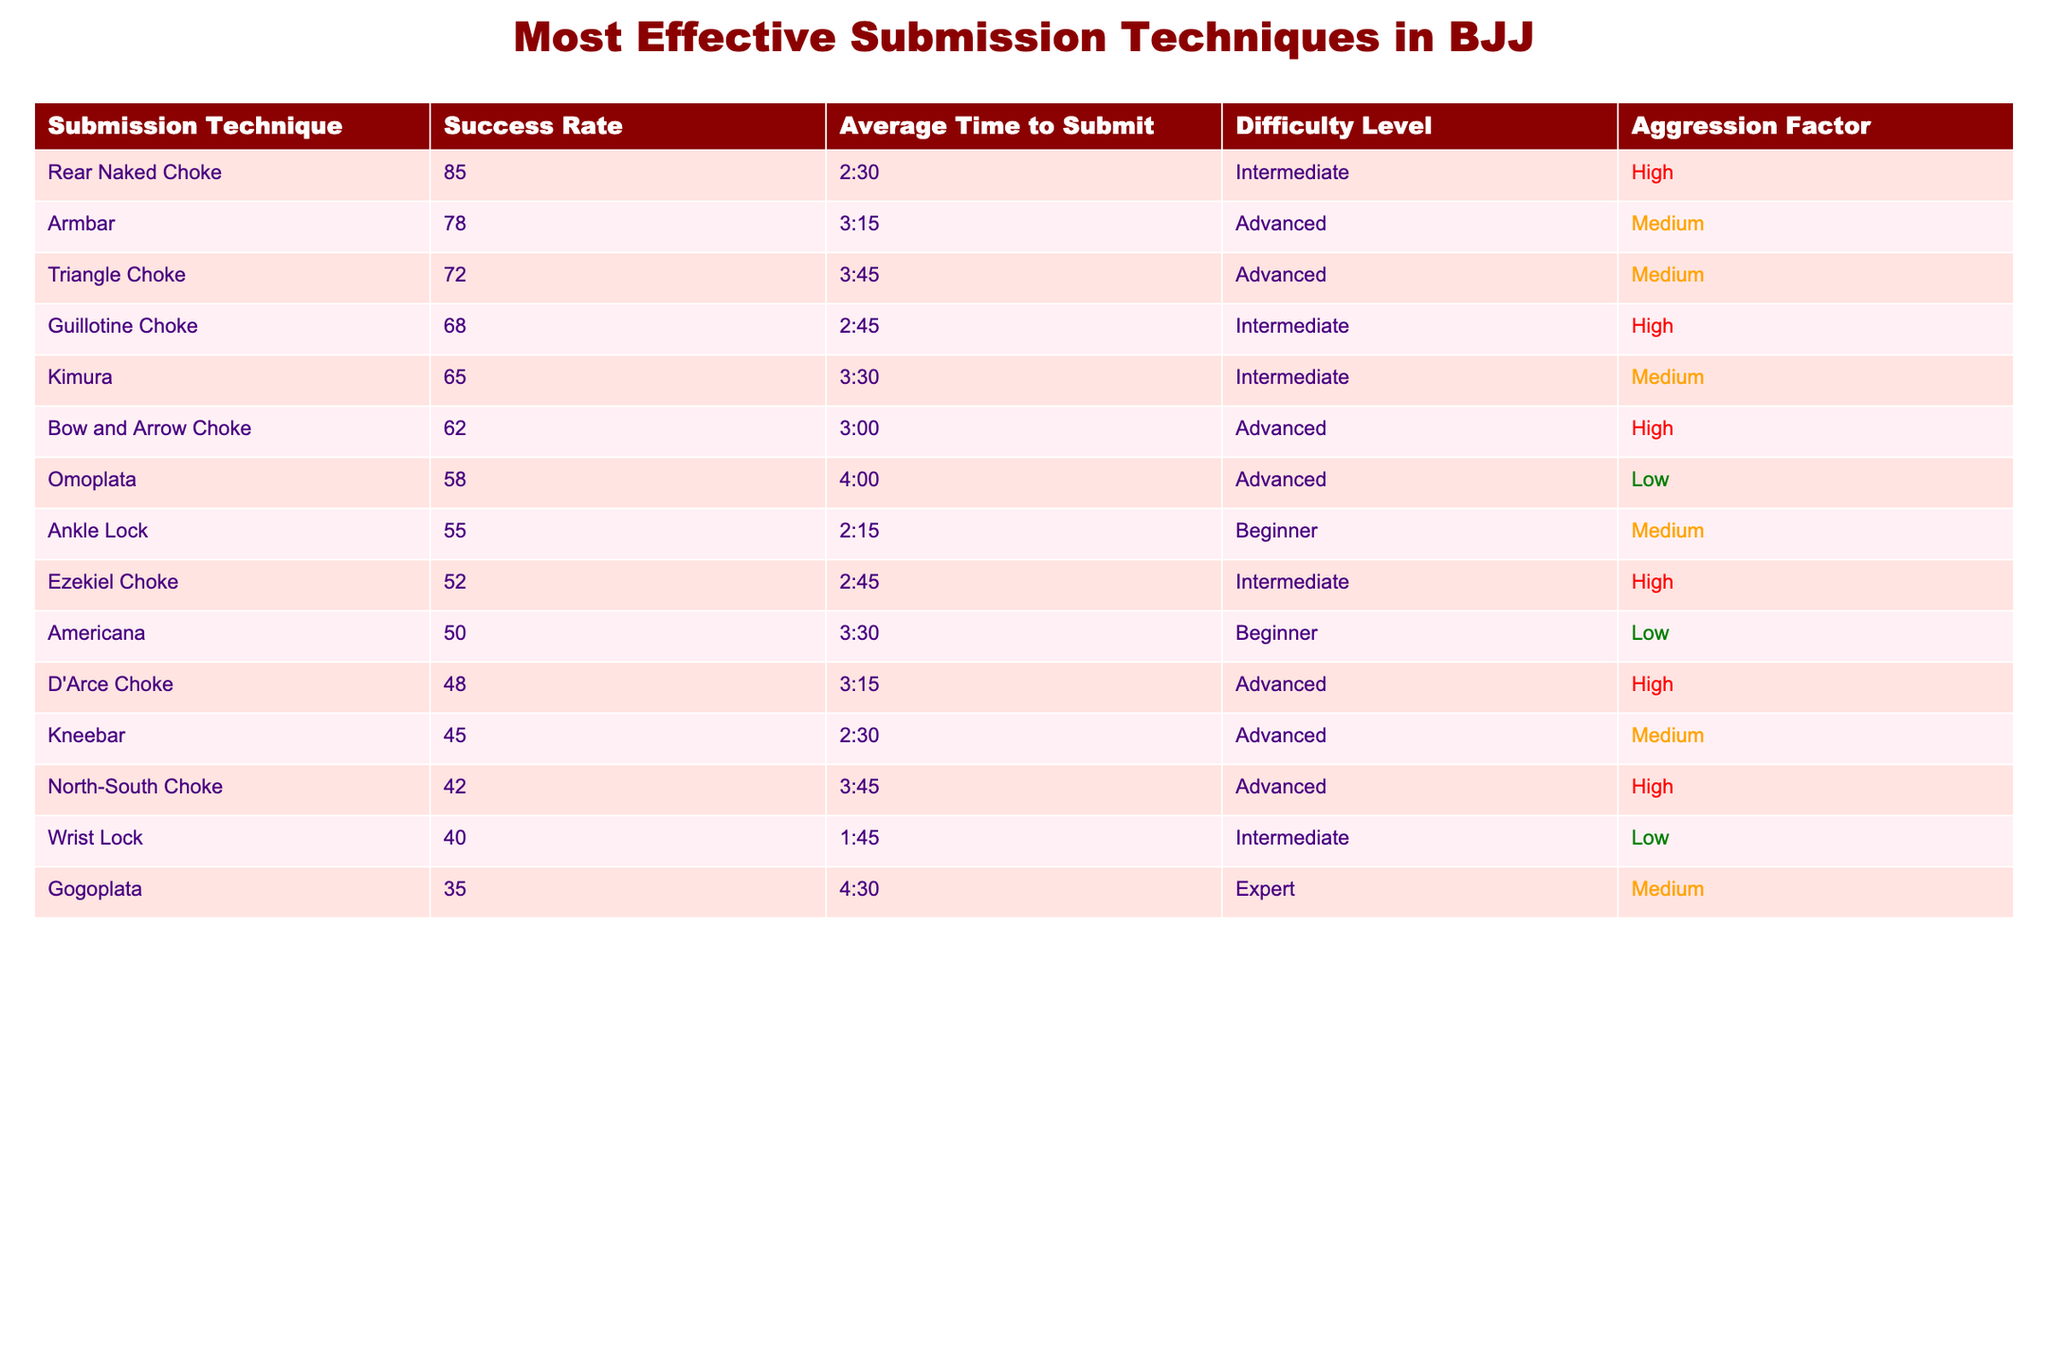What is the submission technique with the highest success rate? The submission technique with the highest success rate is the Rear Naked Choke, which has a success rate of 85%.
Answer: Rear Naked Choke What is the average time to submit for the Armbar? The average time to submit for the Armbar is 3 minutes and 15 seconds, as stated in the table.
Answer: 3:15 Which submission technique has a difficulty level of "Advanced" and a success rate above 70%? The techniques that meet these criteria are Armbar (78%) and Triangle Choke (72%).
Answer: Armbar, Triangle Choke What is the difference in success rate between the Rear Naked Choke and the Ankle Lock? The success rate of Rear Naked Choke is 85% and the Ankle Lock is 55%. So, the difference is 85 - 55 = 30%.
Answer: 30% Is the Guillotine Choke less difficult than the Kimura? Both techniques are categorized as "Intermediate," so the Guillotine Choke is not less difficult than the Kimura.
Answer: No What is the average aggression factor for submission techniques categorized as "Advanced"? The aggression factors for Advanced techniques are High, Medium, High, High, and Medium. The average aggression factor can be determined by interpreting each factor as: High=3, Medium=2, Low=1. Thus, (3+2+3+3+2)/5 = 2.6, which rounds to High on average.
Answer: High What submission technique has the lowest success rate and is classified as "Expert"? The submission technique with the lowest success rate in the table that is classified as "Expert" is the Gogoplata, which has a success rate of 35%.
Answer: Gogoplata If a fighter spends an average of 3 minutes to execute a submission, how many techniques have an average time to submit greater than this? In the table, the techniques with an average time greater than 3 minutes are: Triangle Choke (3:45), Bow and Arrow Choke (3:00), Omoplata (4:00), D'Arce Choke (3:15), Kneebar (2:30), North-South Choke (3:45), and Gogoplata (4:30). The number of these techniques is 5.
Answer: 5 Which submission technique has the shortest average time to submit? The Ankle Lock has the shortest average time to submit at 2 minutes and 15 seconds.
Answer: Ankle Lock Are there any submission techniques with a success rate of 50% or lower? Yes, the techniques with a success rate of 50% or lower are the Americana (50%), D'Arce Choke (48%), Kneebar (45%), North-South Choke (42%), Wrist Lock (40%), and Gogoplata (35%).
Answer: Yes What is the total number of submission techniques listed in the table? There are 14 submission techniques listed in the table, as seen by counting each unique technique row.
Answer: 14 